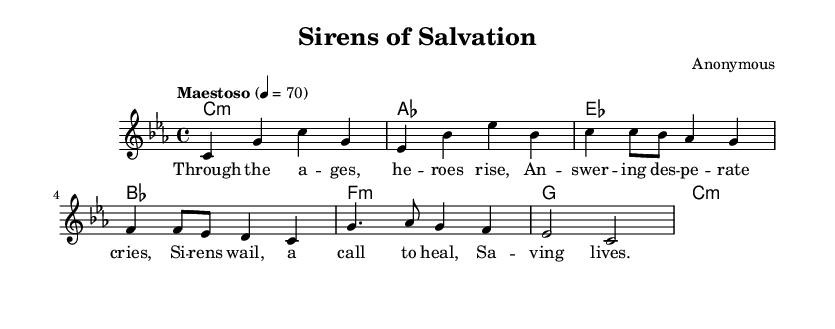What is the key signature of this music? The key signature is C minor, indicated by the presence of three flats (B♭, E♭, A♭).
Answer: C minor What is the time signature of this piece? The time signature displayed in the sheet music is 4/4, meaning there are four beats in each measure and a quarter note receives one beat.
Answer: 4/4 What is the tempo marking of the piece? The tempo marking is "Maestoso," which suggests a majestic and stately pace, set to a subtle beat of 70 for a quarter note.
Answer: Maestoso How many measures does the introduction contain? The introduction has two measures, as indicated by the resting through the four beats shown for each measure in the melody.
Answer: 2 What is the primary emotion conveyed in the lyrics of the chorus? The lyrics express themes of heroism and healing, suggesting a strong sense of urgency and compassion characteristic of emergency medical services.
Answer: Healing How many different chords are used in the harmonies section? The harmonies section includes six unique chords, which are C minor, A♭ major, E♭ major, B♭ major, F minor, and G major, as shown in sequence in the chord names.
Answer: 6 What element makes this piece an opera? This piece qualifies as an opera primarily due to its lyrical content, which tells a story through song, incorporating dramatic themes related to emergency medical services.
Answer: Lyrical content 